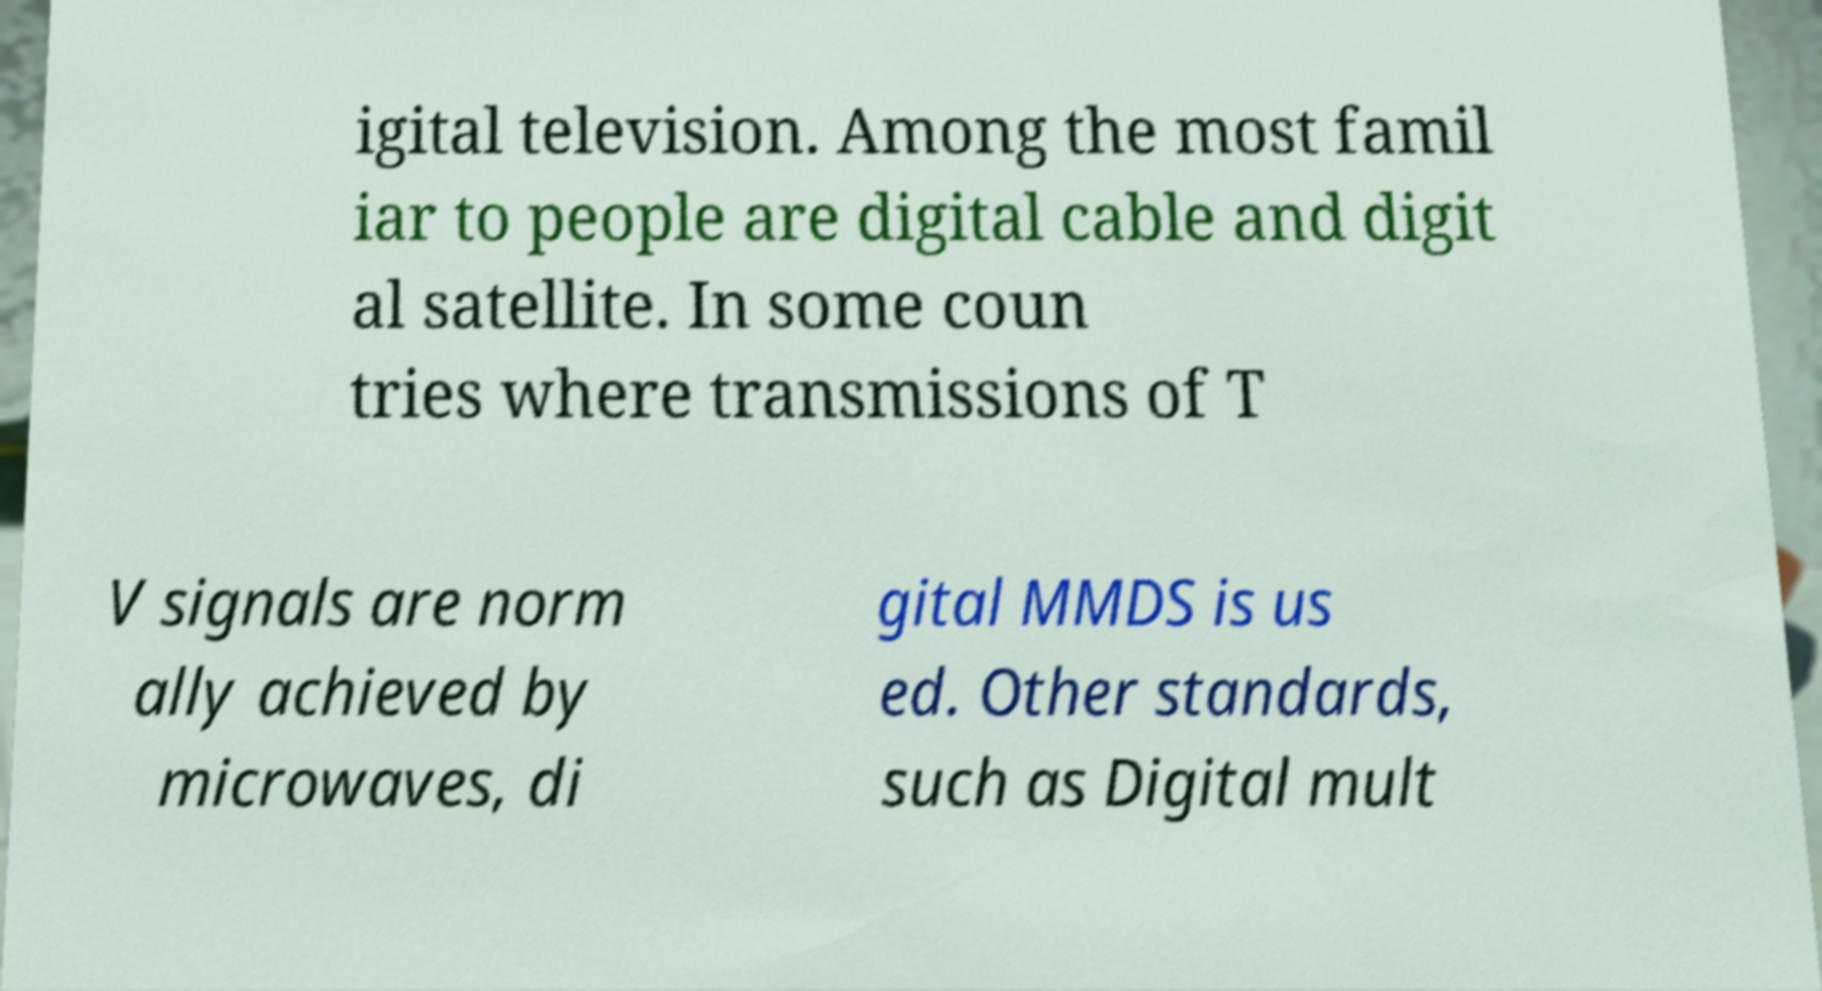Please read and relay the text visible in this image. What does it say? igital television. Among the most famil iar to people are digital cable and digit al satellite. In some coun tries where transmissions of T V signals are norm ally achieved by microwaves, di gital MMDS is us ed. Other standards, such as Digital mult 